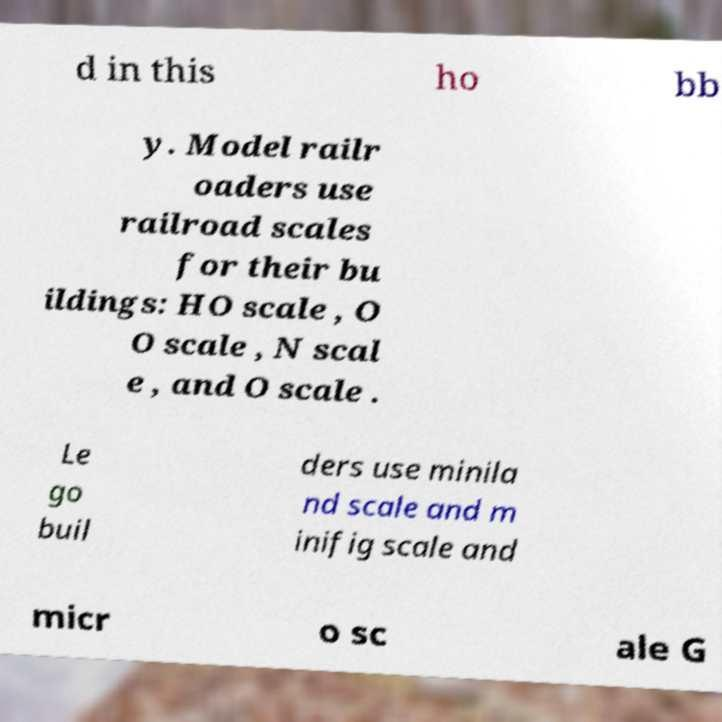Could you assist in decoding the text presented in this image and type it out clearly? d in this ho bb y. Model railr oaders use railroad scales for their bu ildings: HO scale , O O scale , N scal e , and O scale . Le go buil ders use minila nd scale and m inifig scale and micr o sc ale G 